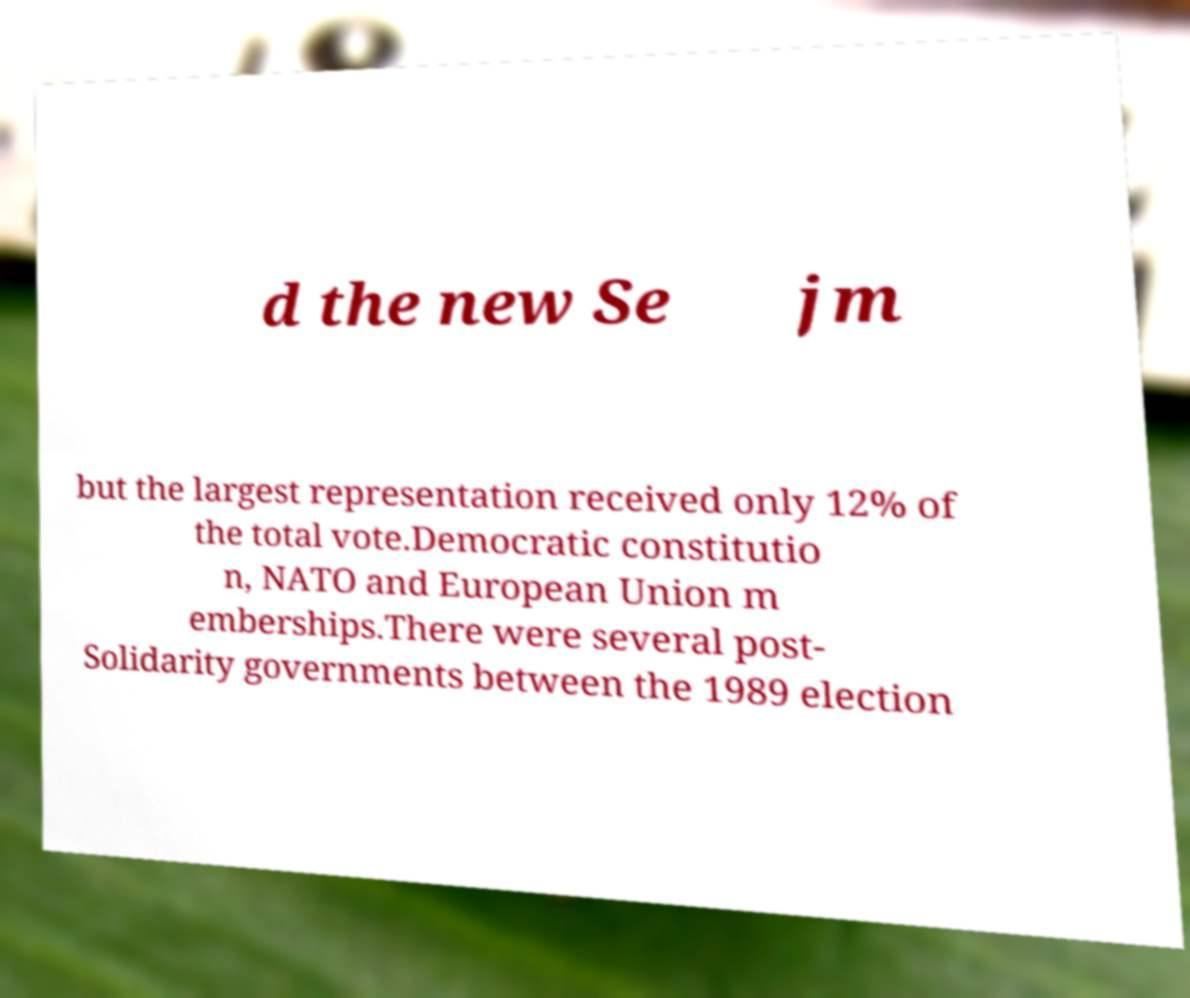Please read and relay the text visible in this image. What does it say? d the new Se jm but the largest representation received only 12% of the total vote.Democratic constitutio n, NATO and European Union m emberships.There were several post- Solidarity governments between the 1989 election 